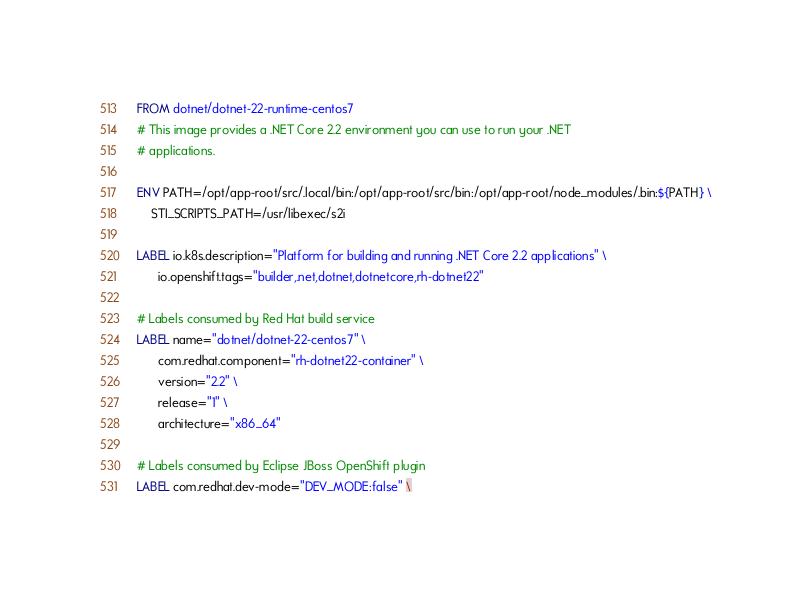<code> <loc_0><loc_0><loc_500><loc_500><_Dockerfile_>FROM dotnet/dotnet-22-runtime-centos7
# This image provides a .NET Core 2.2 environment you can use to run your .NET
# applications.

ENV PATH=/opt/app-root/src/.local/bin:/opt/app-root/src/bin:/opt/app-root/node_modules/.bin:${PATH} \
    STI_SCRIPTS_PATH=/usr/libexec/s2i

LABEL io.k8s.description="Platform for building and running .NET Core 2.2 applications" \
      io.openshift.tags="builder,.net,dotnet,dotnetcore,rh-dotnet22"

# Labels consumed by Red Hat build service
LABEL name="dotnet/dotnet-22-centos7" \
      com.redhat.component="rh-dotnet22-container" \
      version="2.2" \
      release="1" \
      architecture="x86_64"

# Labels consumed by Eclipse JBoss OpenShift plugin
LABEL com.redhat.dev-mode="DEV_MODE:false" \</code> 